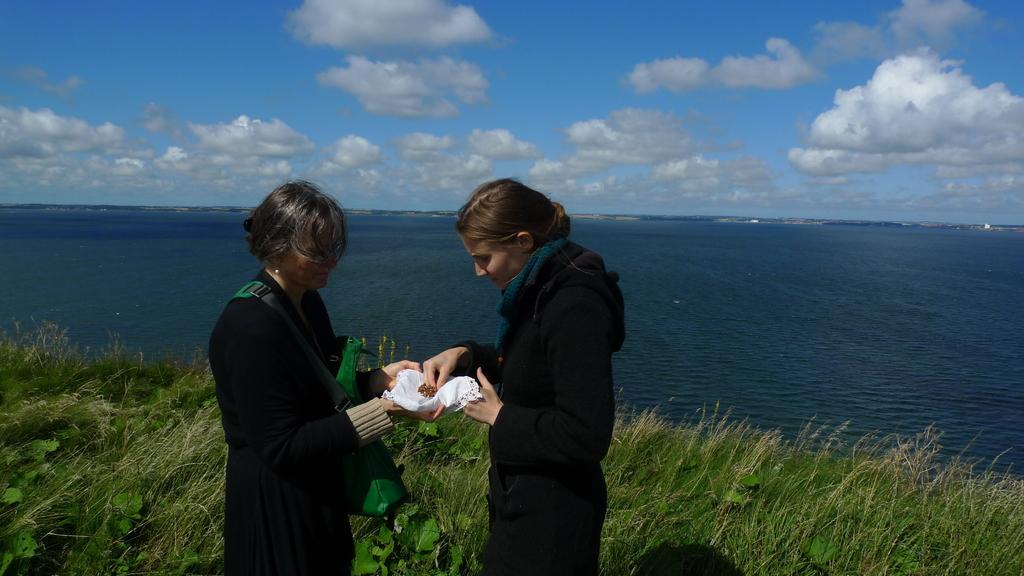In one or two sentences, can you explain what this image depicts? In this picture I can see two persons standing and holding an object. I can see grass, plants, water, and in the background there is the sky. 